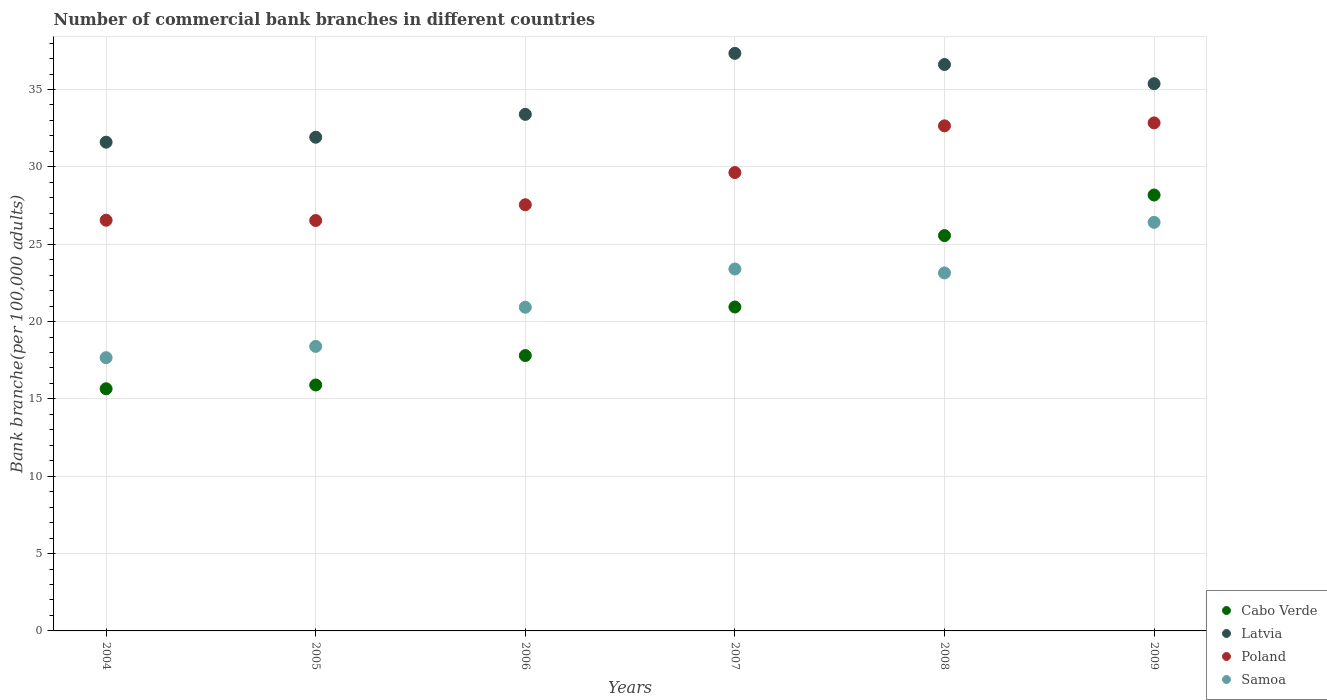How many different coloured dotlines are there?
Make the answer very short. 4. What is the number of commercial bank branches in Cabo Verde in 2008?
Offer a terse response. 25.56. Across all years, what is the maximum number of commercial bank branches in Latvia?
Your answer should be compact. 37.34. Across all years, what is the minimum number of commercial bank branches in Cabo Verde?
Give a very brief answer. 15.65. In which year was the number of commercial bank branches in Samoa maximum?
Offer a very short reply. 2009. In which year was the number of commercial bank branches in Latvia minimum?
Your response must be concise. 2004. What is the total number of commercial bank branches in Poland in the graph?
Provide a short and direct response. 175.76. What is the difference between the number of commercial bank branches in Samoa in 2005 and that in 2007?
Offer a terse response. -5. What is the difference between the number of commercial bank branches in Latvia in 2006 and the number of commercial bank branches in Samoa in 2005?
Offer a very short reply. 15. What is the average number of commercial bank branches in Poland per year?
Your answer should be very brief. 29.29. In the year 2004, what is the difference between the number of commercial bank branches in Cabo Verde and number of commercial bank branches in Samoa?
Your answer should be compact. -2.01. What is the ratio of the number of commercial bank branches in Poland in 2005 to that in 2009?
Keep it short and to the point. 0.81. Is the difference between the number of commercial bank branches in Cabo Verde in 2005 and 2006 greater than the difference between the number of commercial bank branches in Samoa in 2005 and 2006?
Your response must be concise. Yes. What is the difference between the highest and the second highest number of commercial bank branches in Latvia?
Your answer should be very brief. 0.72. What is the difference between the highest and the lowest number of commercial bank branches in Samoa?
Your answer should be very brief. 8.75. In how many years, is the number of commercial bank branches in Cabo Verde greater than the average number of commercial bank branches in Cabo Verde taken over all years?
Ensure brevity in your answer.  3. Is it the case that in every year, the sum of the number of commercial bank branches in Latvia and number of commercial bank branches in Poland  is greater than the number of commercial bank branches in Cabo Verde?
Provide a short and direct response. Yes. Does the number of commercial bank branches in Samoa monotonically increase over the years?
Offer a very short reply. No. Is the number of commercial bank branches in Cabo Verde strictly greater than the number of commercial bank branches in Latvia over the years?
Ensure brevity in your answer.  No. Is the number of commercial bank branches in Poland strictly less than the number of commercial bank branches in Cabo Verde over the years?
Offer a terse response. No. How many dotlines are there?
Your answer should be compact. 4. How many years are there in the graph?
Your answer should be very brief. 6. Does the graph contain any zero values?
Your answer should be very brief. No. What is the title of the graph?
Offer a very short reply. Number of commercial bank branches in different countries. Does "Benin" appear as one of the legend labels in the graph?
Offer a terse response. No. What is the label or title of the X-axis?
Ensure brevity in your answer.  Years. What is the label or title of the Y-axis?
Provide a succinct answer. Bank branche(per 100,0 adults). What is the Bank branche(per 100,000 adults) in Cabo Verde in 2004?
Your answer should be compact. 15.65. What is the Bank branche(per 100,000 adults) in Latvia in 2004?
Provide a succinct answer. 31.6. What is the Bank branche(per 100,000 adults) of Poland in 2004?
Your response must be concise. 26.55. What is the Bank branche(per 100,000 adults) of Samoa in 2004?
Offer a very short reply. 17.66. What is the Bank branche(per 100,000 adults) in Cabo Verde in 2005?
Your answer should be very brief. 15.9. What is the Bank branche(per 100,000 adults) in Latvia in 2005?
Your answer should be very brief. 31.92. What is the Bank branche(per 100,000 adults) of Poland in 2005?
Make the answer very short. 26.53. What is the Bank branche(per 100,000 adults) in Samoa in 2005?
Give a very brief answer. 18.39. What is the Bank branche(per 100,000 adults) of Cabo Verde in 2006?
Your answer should be very brief. 17.8. What is the Bank branche(per 100,000 adults) of Latvia in 2006?
Keep it short and to the point. 33.39. What is the Bank branche(per 100,000 adults) of Poland in 2006?
Make the answer very short. 27.55. What is the Bank branche(per 100,000 adults) of Samoa in 2006?
Provide a succinct answer. 20.92. What is the Bank branche(per 100,000 adults) in Cabo Verde in 2007?
Make the answer very short. 20.94. What is the Bank branche(per 100,000 adults) of Latvia in 2007?
Ensure brevity in your answer.  37.34. What is the Bank branche(per 100,000 adults) in Poland in 2007?
Offer a terse response. 29.63. What is the Bank branche(per 100,000 adults) in Samoa in 2007?
Your answer should be very brief. 23.4. What is the Bank branche(per 100,000 adults) of Cabo Verde in 2008?
Give a very brief answer. 25.56. What is the Bank branche(per 100,000 adults) in Latvia in 2008?
Your response must be concise. 36.62. What is the Bank branche(per 100,000 adults) in Poland in 2008?
Keep it short and to the point. 32.65. What is the Bank branche(per 100,000 adults) of Samoa in 2008?
Provide a short and direct response. 23.14. What is the Bank branche(per 100,000 adults) in Cabo Verde in 2009?
Your response must be concise. 28.18. What is the Bank branche(per 100,000 adults) of Latvia in 2009?
Your response must be concise. 35.38. What is the Bank branche(per 100,000 adults) in Poland in 2009?
Keep it short and to the point. 32.84. What is the Bank branche(per 100,000 adults) in Samoa in 2009?
Offer a terse response. 26.41. Across all years, what is the maximum Bank branche(per 100,000 adults) of Cabo Verde?
Offer a very short reply. 28.18. Across all years, what is the maximum Bank branche(per 100,000 adults) of Latvia?
Make the answer very short. 37.34. Across all years, what is the maximum Bank branche(per 100,000 adults) in Poland?
Keep it short and to the point. 32.84. Across all years, what is the maximum Bank branche(per 100,000 adults) in Samoa?
Provide a succinct answer. 26.41. Across all years, what is the minimum Bank branche(per 100,000 adults) of Cabo Verde?
Your response must be concise. 15.65. Across all years, what is the minimum Bank branche(per 100,000 adults) in Latvia?
Keep it short and to the point. 31.6. Across all years, what is the minimum Bank branche(per 100,000 adults) of Poland?
Keep it short and to the point. 26.53. Across all years, what is the minimum Bank branche(per 100,000 adults) in Samoa?
Provide a short and direct response. 17.66. What is the total Bank branche(per 100,000 adults) in Cabo Verde in the graph?
Offer a very short reply. 124.03. What is the total Bank branche(per 100,000 adults) in Latvia in the graph?
Ensure brevity in your answer.  206.23. What is the total Bank branche(per 100,000 adults) of Poland in the graph?
Make the answer very short. 175.76. What is the total Bank branche(per 100,000 adults) in Samoa in the graph?
Your response must be concise. 129.93. What is the difference between the Bank branche(per 100,000 adults) in Cabo Verde in 2004 and that in 2005?
Ensure brevity in your answer.  -0.24. What is the difference between the Bank branche(per 100,000 adults) in Latvia in 2004 and that in 2005?
Your response must be concise. -0.32. What is the difference between the Bank branche(per 100,000 adults) in Poland in 2004 and that in 2005?
Offer a terse response. 0.02. What is the difference between the Bank branche(per 100,000 adults) in Samoa in 2004 and that in 2005?
Your answer should be very brief. -0.73. What is the difference between the Bank branche(per 100,000 adults) of Cabo Verde in 2004 and that in 2006?
Your answer should be very brief. -2.15. What is the difference between the Bank branche(per 100,000 adults) in Latvia in 2004 and that in 2006?
Your response must be concise. -1.8. What is the difference between the Bank branche(per 100,000 adults) of Poland in 2004 and that in 2006?
Your answer should be compact. -1. What is the difference between the Bank branche(per 100,000 adults) in Samoa in 2004 and that in 2006?
Offer a very short reply. -3.26. What is the difference between the Bank branche(per 100,000 adults) in Cabo Verde in 2004 and that in 2007?
Give a very brief answer. -5.29. What is the difference between the Bank branche(per 100,000 adults) of Latvia in 2004 and that in 2007?
Provide a succinct answer. -5.74. What is the difference between the Bank branche(per 100,000 adults) of Poland in 2004 and that in 2007?
Offer a very short reply. -3.08. What is the difference between the Bank branche(per 100,000 adults) in Samoa in 2004 and that in 2007?
Offer a very short reply. -5.73. What is the difference between the Bank branche(per 100,000 adults) in Cabo Verde in 2004 and that in 2008?
Ensure brevity in your answer.  -9.9. What is the difference between the Bank branche(per 100,000 adults) in Latvia in 2004 and that in 2008?
Make the answer very short. -5.02. What is the difference between the Bank branche(per 100,000 adults) in Poland in 2004 and that in 2008?
Provide a succinct answer. -6.1. What is the difference between the Bank branche(per 100,000 adults) of Samoa in 2004 and that in 2008?
Make the answer very short. -5.48. What is the difference between the Bank branche(per 100,000 adults) of Cabo Verde in 2004 and that in 2009?
Offer a very short reply. -12.53. What is the difference between the Bank branche(per 100,000 adults) of Latvia in 2004 and that in 2009?
Offer a very short reply. -3.78. What is the difference between the Bank branche(per 100,000 adults) in Poland in 2004 and that in 2009?
Ensure brevity in your answer.  -6.29. What is the difference between the Bank branche(per 100,000 adults) in Samoa in 2004 and that in 2009?
Provide a succinct answer. -8.75. What is the difference between the Bank branche(per 100,000 adults) in Cabo Verde in 2005 and that in 2006?
Ensure brevity in your answer.  -1.9. What is the difference between the Bank branche(per 100,000 adults) in Latvia in 2005 and that in 2006?
Your answer should be compact. -1.48. What is the difference between the Bank branche(per 100,000 adults) of Poland in 2005 and that in 2006?
Your response must be concise. -1.02. What is the difference between the Bank branche(per 100,000 adults) of Samoa in 2005 and that in 2006?
Offer a terse response. -2.53. What is the difference between the Bank branche(per 100,000 adults) of Cabo Verde in 2005 and that in 2007?
Offer a very short reply. -5.04. What is the difference between the Bank branche(per 100,000 adults) of Latvia in 2005 and that in 2007?
Your response must be concise. -5.42. What is the difference between the Bank branche(per 100,000 adults) of Poland in 2005 and that in 2007?
Ensure brevity in your answer.  -3.1. What is the difference between the Bank branche(per 100,000 adults) in Samoa in 2005 and that in 2007?
Offer a terse response. -5. What is the difference between the Bank branche(per 100,000 adults) in Cabo Verde in 2005 and that in 2008?
Offer a terse response. -9.66. What is the difference between the Bank branche(per 100,000 adults) in Latvia in 2005 and that in 2008?
Your answer should be compact. -4.7. What is the difference between the Bank branche(per 100,000 adults) in Poland in 2005 and that in 2008?
Your answer should be compact. -6.12. What is the difference between the Bank branche(per 100,000 adults) in Samoa in 2005 and that in 2008?
Give a very brief answer. -4.75. What is the difference between the Bank branche(per 100,000 adults) in Cabo Verde in 2005 and that in 2009?
Keep it short and to the point. -12.28. What is the difference between the Bank branche(per 100,000 adults) of Latvia in 2005 and that in 2009?
Provide a short and direct response. -3.46. What is the difference between the Bank branche(per 100,000 adults) in Poland in 2005 and that in 2009?
Your answer should be compact. -6.31. What is the difference between the Bank branche(per 100,000 adults) of Samoa in 2005 and that in 2009?
Keep it short and to the point. -8.02. What is the difference between the Bank branche(per 100,000 adults) of Cabo Verde in 2006 and that in 2007?
Ensure brevity in your answer.  -3.14. What is the difference between the Bank branche(per 100,000 adults) of Latvia in 2006 and that in 2007?
Provide a short and direct response. -3.94. What is the difference between the Bank branche(per 100,000 adults) in Poland in 2006 and that in 2007?
Provide a succinct answer. -2.08. What is the difference between the Bank branche(per 100,000 adults) in Samoa in 2006 and that in 2007?
Keep it short and to the point. -2.47. What is the difference between the Bank branche(per 100,000 adults) in Cabo Verde in 2006 and that in 2008?
Keep it short and to the point. -7.76. What is the difference between the Bank branche(per 100,000 adults) in Latvia in 2006 and that in 2008?
Your response must be concise. -3.22. What is the difference between the Bank branche(per 100,000 adults) of Poland in 2006 and that in 2008?
Offer a terse response. -5.1. What is the difference between the Bank branche(per 100,000 adults) in Samoa in 2006 and that in 2008?
Offer a very short reply. -2.22. What is the difference between the Bank branche(per 100,000 adults) of Cabo Verde in 2006 and that in 2009?
Give a very brief answer. -10.38. What is the difference between the Bank branche(per 100,000 adults) in Latvia in 2006 and that in 2009?
Offer a very short reply. -1.98. What is the difference between the Bank branche(per 100,000 adults) of Poland in 2006 and that in 2009?
Your answer should be compact. -5.29. What is the difference between the Bank branche(per 100,000 adults) in Samoa in 2006 and that in 2009?
Your response must be concise. -5.49. What is the difference between the Bank branche(per 100,000 adults) of Cabo Verde in 2007 and that in 2008?
Give a very brief answer. -4.62. What is the difference between the Bank branche(per 100,000 adults) of Latvia in 2007 and that in 2008?
Ensure brevity in your answer.  0.72. What is the difference between the Bank branche(per 100,000 adults) in Poland in 2007 and that in 2008?
Ensure brevity in your answer.  -3.02. What is the difference between the Bank branche(per 100,000 adults) of Samoa in 2007 and that in 2008?
Offer a very short reply. 0.26. What is the difference between the Bank branche(per 100,000 adults) in Cabo Verde in 2007 and that in 2009?
Provide a succinct answer. -7.24. What is the difference between the Bank branche(per 100,000 adults) of Latvia in 2007 and that in 2009?
Offer a terse response. 1.96. What is the difference between the Bank branche(per 100,000 adults) in Poland in 2007 and that in 2009?
Your answer should be compact. -3.21. What is the difference between the Bank branche(per 100,000 adults) in Samoa in 2007 and that in 2009?
Make the answer very short. -3.02. What is the difference between the Bank branche(per 100,000 adults) in Cabo Verde in 2008 and that in 2009?
Keep it short and to the point. -2.62. What is the difference between the Bank branche(per 100,000 adults) of Latvia in 2008 and that in 2009?
Offer a terse response. 1.24. What is the difference between the Bank branche(per 100,000 adults) in Poland in 2008 and that in 2009?
Make the answer very short. -0.19. What is the difference between the Bank branche(per 100,000 adults) of Samoa in 2008 and that in 2009?
Your answer should be compact. -3.27. What is the difference between the Bank branche(per 100,000 adults) in Cabo Verde in 2004 and the Bank branche(per 100,000 adults) in Latvia in 2005?
Your answer should be very brief. -16.26. What is the difference between the Bank branche(per 100,000 adults) in Cabo Verde in 2004 and the Bank branche(per 100,000 adults) in Poland in 2005?
Provide a short and direct response. -10.88. What is the difference between the Bank branche(per 100,000 adults) in Cabo Verde in 2004 and the Bank branche(per 100,000 adults) in Samoa in 2005?
Provide a short and direct response. -2.74. What is the difference between the Bank branche(per 100,000 adults) in Latvia in 2004 and the Bank branche(per 100,000 adults) in Poland in 2005?
Make the answer very short. 5.06. What is the difference between the Bank branche(per 100,000 adults) of Latvia in 2004 and the Bank branche(per 100,000 adults) of Samoa in 2005?
Keep it short and to the point. 13.2. What is the difference between the Bank branche(per 100,000 adults) in Poland in 2004 and the Bank branche(per 100,000 adults) in Samoa in 2005?
Your answer should be compact. 8.16. What is the difference between the Bank branche(per 100,000 adults) of Cabo Verde in 2004 and the Bank branche(per 100,000 adults) of Latvia in 2006?
Make the answer very short. -17.74. What is the difference between the Bank branche(per 100,000 adults) in Cabo Verde in 2004 and the Bank branche(per 100,000 adults) in Poland in 2006?
Provide a short and direct response. -11.9. What is the difference between the Bank branche(per 100,000 adults) of Cabo Verde in 2004 and the Bank branche(per 100,000 adults) of Samoa in 2006?
Give a very brief answer. -5.27. What is the difference between the Bank branche(per 100,000 adults) of Latvia in 2004 and the Bank branche(per 100,000 adults) of Poland in 2006?
Your response must be concise. 4.04. What is the difference between the Bank branche(per 100,000 adults) in Latvia in 2004 and the Bank branche(per 100,000 adults) in Samoa in 2006?
Offer a very short reply. 10.67. What is the difference between the Bank branche(per 100,000 adults) in Poland in 2004 and the Bank branche(per 100,000 adults) in Samoa in 2006?
Offer a terse response. 5.63. What is the difference between the Bank branche(per 100,000 adults) in Cabo Verde in 2004 and the Bank branche(per 100,000 adults) in Latvia in 2007?
Keep it short and to the point. -21.68. What is the difference between the Bank branche(per 100,000 adults) in Cabo Verde in 2004 and the Bank branche(per 100,000 adults) in Poland in 2007?
Offer a terse response. -13.98. What is the difference between the Bank branche(per 100,000 adults) of Cabo Verde in 2004 and the Bank branche(per 100,000 adults) of Samoa in 2007?
Make the answer very short. -7.74. What is the difference between the Bank branche(per 100,000 adults) in Latvia in 2004 and the Bank branche(per 100,000 adults) in Poland in 2007?
Your response must be concise. 1.96. What is the difference between the Bank branche(per 100,000 adults) of Latvia in 2004 and the Bank branche(per 100,000 adults) of Samoa in 2007?
Your answer should be very brief. 8.2. What is the difference between the Bank branche(per 100,000 adults) of Poland in 2004 and the Bank branche(per 100,000 adults) of Samoa in 2007?
Your answer should be very brief. 3.15. What is the difference between the Bank branche(per 100,000 adults) in Cabo Verde in 2004 and the Bank branche(per 100,000 adults) in Latvia in 2008?
Your answer should be very brief. -20.96. What is the difference between the Bank branche(per 100,000 adults) of Cabo Verde in 2004 and the Bank branche(per 100,000 adults) of Poland in 2008?
Keep it short and to the point. -17. What is the difference between the Bank branche(per 100,000 adults) in Cabo Verde in 2004 and the Bank branche(per 100,000 adults) in Samoa in 2008?
Ensure brevity in your answer.  -7.49. What is the difference between the Bank branche(per 100,000 adults) in Latvia in 2004 and the Bank branche(per 100,000 adults) in Poland in 2008?
Make the answer very short. -1.06. What is the difference between the Bank branche(per 100,000 adults) of Latvia in 2004 and the Bank branche(per 100,000 adults) of Samoa in 2008?
Give a very brief answer. 8.45. What is the difference between the Bank branche(per 100,000 adults) in Poland in 2004 and the Bank branche(per 100,000 adults) in Samoa in 2008?
Offer a very short reply. 3.41. What is the difference between the Bank branche(per 100,000 adults) of Cabo Verde in 2004 and the Bank branche(per 100,000 adults) of Latvia in 2009?
Your answer should be compact. -19.72. What is the difference between the Bank branche(per 100,000 adults) of Cabo Verde in 2004 and the Bank branche(per 100,000 adults) of Poland in 2009?
Give a very brief answer. -17.19. What is the difference between the Bank branche(per 100,000 adults) in Cabo Verde in 2004 and the Bank branche(per 100,000 adults) in Samoa in 2009?
Your answer should be compact. -10.76. What is the difference between the Bank branche(per 100,000 adults) in Latvia in 2004 and the Bank branche(per 100,000 adults) in Poland in 2009?
Provide a short and direct response. -1.25. What is the difference between the Bank branche(per 100,000 adults) in Latvia in 2004 and the Bank branche(per 100,000 adults) in Samoa in 2009?
Give a very brief answer. 5.18. What is the difference between the Bank branche(per 100,000 adults) in Poland in 2004 and the Bank branche(per 100,000 adults) in Samoa in 2009?
Your response must be concise. 0.14. What is the difference between the Bank branche(per 100,000 adults) of Cabo Verde in 2005 and the Bank branche(per 100,000 adults) of Latvia in 2006?
Offer a very short reply. -17.49. What is the difference between the Bank branche(per 100,000 adults) of Cabo Verde in 2005 and the Bank branche(per 100,000 adults) of Poland in 2006?
Ensure brevity in your answer.  -11.65. What is the difference between the Bank branche(per 100,000 adults) in Cabo Verde in 2005 and the Bank branche(per 100,000 adults) in Samoa in 2006?
Keep it short and to the point. -5.02. What is the difference between the Bank branche(per 100,000 adults) in Latvia in 2005 and the Bank branche(per 100,000 adults) in Poland in 2006?
Ensure brevity in your answer.  4.36. What is the difference between the Bank branche(per 100,000 adults) of Latvia in 2005 and the Bank branche(per 100,000 adults) of Samoa in 2006?
Offer a very short reply. 10.99. What is the difference between the Bank branche(per 100,000 adults) in Poland in 2005 and the Bank branche(per 100,000 adults) in Samoa in 2006?
Your answer should be very brief. 5.61. What is the difference between the Bank branche(per 100,000 adults) in Cabo Verde in 2005 and the Bank branche(per 100,000 adults) in Latvia in 2007?
Give a very brief answer. -21.44. What is the difference between the Bank branche(per 100,000 adults) in Cabo Verde in 2005 and the Bank branche(per 100,000 adults) in Poland in 2007?
Your answer should be compact. -13.73. What is the difference between the Bank branche(per 100,000 adults) in Cabo Verde in 2005 and the Bank branche(per 100,000 adults) in Samoa in 2007?
Give a very brief answer. -7.5. What is the difference between the Bank branche(per 100,000 adults) in Latvia in 2005 and the Bank branche(per 100,000 adults) in Poland in 2007?
Give a very brief answer. 2.28. What is the difference between the Bank branche(per 100,000 adults) in Latvia in 2005 and the Bank branche(per 100,000 adults) in Samoa in 2007?
Your response must be concise. 8.52. What is the difference between the Bank branche(per 100,000 adults) in Poland in 2005 and the Bank branche(per 100,000 adults) in Samoa in 2007?
Your answer should be very brief. 3.13. What is the difference between the Bank branche(per 100,000 adults) of Cabo Verde in 2005 and the Bank branche(per 100,000 adults) of Latvia in 2008?
Offer a very short reply. -20.72. What is the difference between the Bank branche(per 100,000 adults) in Cabo Verde in 2005 and the Bank branche(per 100,000 adults) in Poland in 2008?
Provide a short and direct response. -16.75. What is the difference between the Bank branche(per 100,000 adults) of Cabo Verde in 2005 and the Bank branche(per 100,000 adults) of Samoa in 2008?
Your response must be concise. -7.24. What is the difference between the Bank branche(per 100,000 adults) in Latvia in 2005 and the Bank branche(per 100,000 adults) in Poland in 2008?
Your answer should be compact. -0.74. What is the difference between the Bank branche(per 100,000 adults) of Latvia in 2005 and the Bank branche(per 100,000 adults) of Samoa in 2008?
Offer a terse response. 8.77. What is the difference between the Bank branche(per 100,000 adults) of Poland in 2005 and the Bank branche(per 100,000 adults) of Samoa in 2008?
Give a very brief answer. 3.39. What is the difference between the Bank branche(per 100,000 adults) in Cabo Verde in 2005 and the Bank branche(per 100,000 adults) in Latvia in 2009?
Provide a short and direct response. -19.48. What is the difference between the Bank branche(per 100,000 adults) in Cabo Verde in 2005 and the Bank branche(per 100,000 adults) in Poland in 2009?
Keep it short and to the point. -16.94. What is the difference between the Bank branche(per 100,000 adults) in Cabo Verde in 2005 and the Bank branche(per 100,000 adults) in Samoa in 2009?
Offer a very short reply. -10.51. What is the difference between the Bank branche(per 100,000 adults) in Latvia in 2005 and the Bank branche(per 100,000 adults) in Poland in 2009?
Ensure brevity in your answer.  -0.93. What is the difference between the Bank branche(per 100,000 adults) in Latvia in 2005 and the Bank branche(per 100,000 adults) in Samoa in 2009?
Offer a terse response. 5.5. What is the difference between the Bank branche(per 100,000 adults) of Poland in 2005 and the Bank branche(per 100,000 adults) of Samoa in 2009?
Ensure brevity in your answer.  0.12. What is the difference between the Bank branche(per 100,000 adults) in Cabo Verde in 2006 and the Bank branche(per 100,000 adults) in Latvia in 2007?
Give a very brief answer. -19.54. What is the difference between the Bank branche(per 100,000 adults) in Cabo Verde in 2006 and the Bank branche(per 100,000 adults) in Poland in 2007?
Make the answer very short. -11.83. What is the difference between the Bank branche(per 100,000 adults) in Cabo Verde in 2006 and the Bank branche(per 100,000 adults) in Samoa in 2007?
Your answer should be compact. -5.6. What is the difference between the Bank branche(per 100,000 adults) of Latvia in 2006 and the Bank branche(per 100,000 adults) of Poland in 2007?
Ensure brevity in your answer.  3.76. What is the difference between the Bank branche(per 100,000 adults) in Latvia in 2006 and the Bank branche(per 100,000 adults) in Samoa in 2007?
Make the answer very short. 10. What is the difference between the Bank branche(per 100,000 adults) of Poland in 2006 and the Bank branche(per 100,000 adults) of Samoa in 2007?
Your response must be concise. 4.15. What is the difference between the Bank branche(per 100,000 adults) of Cabo Verde in 2006 and the Bank branche(per 100,000 adults) of Latvia in 2008?
Your answer should be very brief. -18.81. What is the difference between the Bank branche(per 100,000 adults) of Cabo Verde in 2006 and the Bank branche(per 100,000 adults) of Poland in 2008?
Offer a terse response. -14.85. What is the difference between the Bank branche(per 100,000 adults) of Cabo Verde in 2006 and the Bank branche(per 100,000 adults) of Samoa in 2008?
Make the answer very short. -5.34. What is the difference between the Bank branche(per 100,000 adults) in Latvia in 2006 and the Bank branche(per 100,000 adults) in Poland in 2008?
Keep it short and to the point. 0.74. What is the difference between the Bank branche(per 100,000 adults) of Latvia in 2006 and the Bank branche(per 100,000 adults) of Samoa in 2008?
Your answer should be compact. 10.25. What is the difference between the Bank branche(per 100,000 adults) of Poland in 2006 and the Bank branche(per 100,000 adults) of Samoa in 2008?
Provide a short and direct response. 4.41. What is the difference between the Bank branche(per 100,000 adults) in Cabo Verde in 2006 and the Bank branche(per 100,000 adults) in Latvia in 2009?
Provide a succinct answer. -17.57. What is the difference between the Bank branche(per 100,000 adults) in Cabo Verde in 2006 and the Bank branche(per 100,000 adults) in Poland in 2009?
Provide a short and direct response. -15.04. What is the difference between the Bank branche(per 100,000 adults) in Cabo Verde in 2006 and the Bank branche(per 100,000 adults) in Samoa in 2009?
Keep it short and to the point. -8.61. What is the difference between the Bank branche(per 100,000 adults) of Latvia in 2006 and the Bank branche(per 100,000 adults) of Poland in 2009?
Offer a terse response. 0.55. What is the difference between the Bank branche(per 100,000 adults) in Latvia in 2006 and the Bank branche(per 100,000 adults) in Samoa in 2009?
Make the answer very short. 6.98. What is the difference between the Bank branche(per 100,000 adults) in Poland in 2006 and the Bank branche(per 100,000 adults) in Samoa in 2009?
Make the answer very short. 1.14. What is the difference between the Bank branche(per 100,000 adults) of Cabo Verde in 2007 and the Bank branche(per 100,000 adults) of Latvia in 2008?
Offer a terse response. -15.68. What is the difference between the Bank branche(per 100,000 adults) of Cabo Verde in 2007 and the Bank branche(per 100,000 adults) of Poland in 2008?
Offer a very short reply. -11.71. What is the difference between the Bank branche(per 100,000 adults) in Cabo Verde in 2007 and the Bank branche(per 100,000 adults) in Samoa in 2008?
Offer a very short reply. -2.2. What is the difference between the Bank branche(per 100,000 adults) of Latvia in 2007 and the Bank branche(per 100,000 adults) of Poland in 2008?
Make the answer very short. 4.69. What is the difference between the Bank branche(per 100,000 adults) of Latvia in 2007 and the Bank branche(per 100,000 adults) of Samoa in 2008?
Make the answer very short. 14.2. What is the difference between the Bank branche(per 100,000 adults) in Poland in 2007 and the Bank branche(per 100,000 adults) in Samoa in 2008?
Offer a terse response. 6.49. What is the difference between the Bank branche(per 100,000 adults) of Cabo Verde in 2007 and the Bank branche(per 100,000 adults) of Latvia in 2009?
Provide a succinct answer. -14.44. What is the difference between the Bank branche(per 100,000 adults) of Cabo Verde in 2007 and the Bank branche(per 100,000 adults) of Poland in 2009?
Make the answer very short. -11.9. What is the difference between the Bank branche(per 100,000 adults) in Cabo Verde in 2007 and the Bank branche(per 100,000 adults) in Samoa in 2009?
Ensure brevity in your answer.  -5.47. What is the difference between the Bank branche(per 100,000 adults) in Latvia in 2007 and the Bank branche(per 100,000 adults) in Poland in 2009?
Give a very brief answer. 4.5. What is the difference between the Bank branche(per 100,000 adults) of Latvia in 2007 and the Bank branche(per 100,000 adults) of Samoa in 2009?
Your answer should be very brief. 10.93. What is the difference between the Bank branche(per 100,000 adults) of Poland in 2007 and the Bank branche(per 100,000 adults) of Samoa in 2009?
Your answer should be compact. 3.22. What is the difference between the Bank branche(per 100,000 adults) of Cabo Verde in 2008 and the Bank branche(per 100,000 adults) of Latvia in 2009?
Your answer should be very brief. -9.82. What is the difference between the Bank branche(per 100,000 adults) in Cabo Verde in 2008 and the Bank branche(per 100,000 adults) in Poland in 2009?
Make the answer very short. -7.28. What is the difference between the Bank branche(per 100,000 adults) of Cabo Verde in 2008 and the Bank branche(per 100,000 adults) of Samoa in 2009?
Keep it short and to the point. -0.86. What is the difference between the Bank branche(per 100,000 adults) of Latvia in 2008 and the Bank branche(per 100,000 adults) of Poland in 2009?
Your response must be concise. 3.77. What is the difference between the Bank branche(per 100,000 adults) of Latvia in 2008 and the Bank branche(per 100,000 adults) of Samoa in 2009?
Your response must be concise. 10.2. What is the difference between the Bank branche(per 100,000 adults) of Poland in 2008 and the Bank branche(per 100,000 adults) of Samoa in 2009?
Provide a short and direct response. 6.24. What is the average Bank branche(per 100,000 adults) of Cabo Verde per year?
Keep it short and to the point. 20.67. What is the average Bank branche(per 100,000 adults) in Latvia per year?
Your response must be concise. 34.37. What is the average Bank branche(per 100,000 adults) of Poland per year?
Your response must be concise. 29.29. What is the average Bank branche(per 100,000 adults) in Samoa per year?
Make the answer very short. 21.66. In the year 2004, what is the difference between the Bank branche(per 100,000 adults) of Cabo Verde and Bank branche(per 100,000 adults) of Latvia?
Your response must be concise. -15.94. In the year 2004, what is the difference between the Bank branche(per 100,000 adults) of Cabo Verde and Bank branche(per 100,000 adults) of Poland?
Your answer should be compact. -10.9. In the year 2004, what is the difference between the Bank branche(per 100,000 adults) of Cabo Verde and Bank branche(per 100,000 adults) of Samoa?
Ensure brevity in your answer.  -2.01. In the year 2004, what is the difference between the Bank branche(per 100,000 adults) in Latvia and Bank branche(per 100,000 adults) in Poland?
Your answer should be compact. 5.04. In the year 2004, what is the difference between the Bank branche(per 100,000 adults) of Latvia and Bank branche(per 100,000 adults) of Samoa?
Your answer should be compact. 13.93. In the year 2004, what is the difference between the Bank branche(per 100,000 adults) of Poland and Bank branche(per 100,000 adults) of Samoa?
Your answer should be very brief. 8.89. In the year 2005, what is the difference between the Bank branche(per 100,000 adults) in Cabo Verde and Bank branche(per 100,000 adults) in Latvia?
Give a very brief answer. -16.02. In the year 2005, what is the difference between the Bank branche(per 100,000 adults) in Cabo Verde and Bank branche(per 100,000 adults) in Poland?
Keep it short and to the point. -10.63. In the year 2005, what is the difference between the Bank branche(per 100,000 adults) in Cabo Verde and Bank branche(per 100,000 adults) in Samoa?
Offer a terse response. -2.49. In the year 2005, what is the difference between the Bank branche(per 100,000 adults) in Latvia and Bank branche(per 100,000 adults) in Poland?
Ensure brevity in your answer.  5.38. In the year 2005, what is the difference between the Bank branche(per 100,000 adults) of Latvia and Bank branche(per 100,000 adults) of Samoa?
Provide a short and direct response. 13.52. In the year 2005, what is the difference between the Bank branche(per 100,000 adults) in Poland and Bank branche(per 100,000 adults) in Samoa?
Your answer should be very brief. 8.14. In the year 2006, what is the difference between the Bank branche(per 100,000 adults) in Cabo Verde and Bank branche(per 100,000 adults) in Latvia?
Make the answer very short. -15.59. In the year 2006, what is the difference between the Bank branche(per 100,000 adults) of Cabo Verde and Bank branche(per 100,000 adults) of Poland?
Your response must be concise. -9.75. In the year 2006, what is the difference between the Bank branche(per 100,000 adults) of Cabo Verde and Bank branche(per 100,000 adults) of Samoa?
Your answer should be compact. -3.12. In the year 2006, what is the difference between the Bank branche(per 100,000 adults) of Latvia and Bank branche(per 100,000 adults) of Poland?
Your answer should be compact. 5.84. In the year 2006, what is the difference between the Bank branche(per 100,000 adults) in Latvia and Bank branche(per 100,000 adults) in Samoa?
Make the answer very short. 12.47. In the year 2006, what is the difference between the Bank branche(per 100,000 adults) of Poland and Bank branche(per 100,000 adults) of Samoa?
Give a very brief answer. 6.63. In the year 2007, what is the difference between the Bank branche(per 100,000 adults) in Cabo Verde and Bank branche(per 100,000 adults) in Latvia?
Provide a short and direct response. -16.4. In the year 2007, what is the difference between the Bank branche(per 100,000 adults) of Cabo Verde and Bank branche(per 100,000 adults) of Poland?
Keep it short and to the point. -8.69. In the year 2007, what is the difference between the Bank branche(per 100,000 adults) of Cabo Verde and Bank branche(per 100,000 adults) of Samoa?
Your response must be concise. -2.46. In the year 2007, what is the difference between the Bank branche(per 100,000 adults) in Latvia and Bank branche(per 100,000 adults) in Poland?
Provide a succinct answer. 7.71. In the year 2007, what is the difference between the Bank branche(per 100,000 adults) of Latvia and Bank branche(per 100,000 adults) of Samoa?
Offer a very short reply. 13.94. In the year 2007, what is the difference between the Bank branche(per 100,000 adults) of Poland and Bank branche(per 100,000 adults) of Samoa?
Provide a short and direct response. 6.24. In the year 2008, what is the difference between the Bank branche(per 100,000 adults) of Cabo Verde and Bank branche(per 100,000 adults) of Latvia?
Provide a short and direct response. -11.06. In the year 2008, what is the difference between the Bank branche(per 100,000 adults) of Cabo Verde and Bank branche(per 100,000 adults) of Poland?
Keep it short and to the point. -7.09. In the year 2008, what is the difference between the Bank branche(per 100,000 adults) of Cabo Verde and Bank branche(per 100,000 adults) of Samoa?
Your answer should be very brief. 2.41. In the year 2008, what is the difference between the Bank branche(per 100,000 adults) in Latvia and Bank branche(per 100,000 adults) in Poland?
Make the answer very short. 3.96. In the year 2008, what is the difference between the Bank branche(per 100,000 adults) in Latvia and Bank branche(per 100,000 adults) in Samoa?
Your response must be concise. 13.47. In the year 2008, what is the difference between the Bank branche(per 100,000 adults) in Poland and Bank branche(per 100,000 adults) in Samoa?
Offer a very short reply. 9.51. In the year 2009, what is the difference between the Bank branche(per 100,000 adults) of Cabo Verde and Bank branche(per 100,000 adults) of Latvia?
Make the answer very short. -7.2. In the year 2009, what is the difference between the Bank branche(per 100,000 adults) of Cabo Verde and Bank branche(per 100,000 adults) of Poland?
Give a very brief answer. -4.66. In the year 2009, what is the difference between the Bank branche(per 100,000 adults) in Cabo Verde and Bank branche(per 100,000 adults) in Samoa?
Give a very brief answer. 1.77. In the year 2009, what is the difference between the Bank branche(per 100,000 adults) in Latvia and Bank branche(per 100,000 adults) in Poland?
Make the answer very short. 2.53. In the year 2009, what is the difference between the Bank branche(per 100,000 adults) of Latvia and Bank branche(per 100,000 adults) of Samoa?
Provide a short and direct response. 8.96. In the year 2009, what is the difference between the Bank branche(per 100,000 adults) of Poland and Bank branche(per 100,000 adults) of Samoa?
Ensure brevity in your answer.  6.43. What is the ratio of the Bank branche(per 100,000 adults) in Cabo Verde in 2004 to that in 2005?
Offer a very short reply. 0.98. What is the ratio of the Bank branche(per 100,000 adults) of Latvia in 2004 to that in 2005?
Your answer should be compact. 0.99. What is the ratio of the Bank branche(per 100,000 adults) of Poland in 2004 to that in 2005?
Offer a very short reply. 1. What is the ratio of the Bank branche(per 100,000 adults) of Samoa in 2004 to that in 2005?
Ensure brevity in your answer.  0.96. What is the ratio of the Bank branche(per 100,000 adults) in Cabo Verde in 2004 to that in 2006?
Your response must be concise. 0.88. What is the ratio of the Bank branche(per 100,000 adults) of Latvia in 2004 to that in 2006?
Provide a short and direct response. 0.95. What is the ratio of the Bank branche(per 100,000 adults) in Poland in 2004 to that in 2006?
Offer a terse response. 0.96. What is the ratio of the Bank branche(per 100,000 adults) in Samoa in 2004 to that in 2006?
Give a very brief answer. 0.84. What is the ratio of the Bank branche(per 100,000 adults) in Cabo Verde in 2004 to that in 2007?
Give a very brief answer. 0.75. What is the ratio of the Bank branche(per 100,000 adults) of Latvia in 2004 to that in 2007?
Your response must be concise. 0.85. What is the ratio of the Bank branche(per 100,000 adults) of Poland in 2004 to that in 2007?
Make the answer very short. 0.9. What is the ratio of the Bank branche(per 100,000 adults) in Samoa in 2004 to that in 2007?
Give a very brief answer. 0.76. What is the ratio of the Bank branche(per 100,000 adults) in Cabo Verde in 2004 to that in 2008?
Provide a short and direct response. 0.61. What is the ratio of the Bank branche(per 100,000 adults) in Latvia in 2004 to that in 2008?
Your answer should be compact. 0.86. What is the ratio of the Bank branche(per 100,000 adults) of Poland in 2004 to that in 2008?
Give a very brief answer. 0.81. What is the ratio of the Bank branche(per 100,000 adults) of Samoa in 2004 to that in 2008?
Give a very brief answer. 0.76. What is the ratio of the Bank branche(per 100,000 adults) of Cabo Verde in 2004 to that in 2009?
Give a very brief answer. 0.56. What is the ratio of the Bank branche(per 100,000 adults) of Latvia in 2004 to that in 2009?
Keep it short and to the point. 0.89. What is the ratio of the Bank branche(per 100,000 adults) in Poland in 2004 to that in 2009?
Provide a short and direct response. 0.81. What is the ratio of the Bank branche(per 100,000 adults) of Samoa in 2004 to that in 2009?
Keep it short and to the point. 0.67. What is the ratio of the Bank branche(per 100,000 adults) of Cabo Verde in 2005 to that in 2006?
Provide a short and direct response. 0.89. What is the ratio of the Bank branche(per 100,000 adults) of Latvia in 2005 to that in 2006?
Your response must be concise. 0.96. What is the ratio of the Bank branche(per 100,000 adults) of Samoa in 2005 to that in 2006?
Give a very brief answer. 0.88. What is the ratio of the Bank branche(per 100,000 adults) in Cabo Verde in 2005 to that in 2007?
Provide a short and direct response. 0.76. What is the ratio of the Bank branche(per 100,000 adults) in Latvia in 2005 to that in 2007?
Your answer should be very brief. 0.85. What is the ratio of the Bank branche(per 100,000 adults) of Poland in 2005 to that in 2007?
Offer a very short reply. 0.9. What is the ratio of the Bank branche(per 100,000 adults) of Samoa in 2005 to that in 2007?
Provide a short and direct response. 0.79. What is the ratio of the Bank branche(per 100,000 adults) of Cabo Verde in 2005 to that in 2008?
Your response must be concise. 0.62. What is the ratio of the Bank branche(per 100,000 adults) of Latvia in 2005 to that in 2008?
Make the answer very short. 0.87. What is the ratio of the Bank branche(per 100,000 adults) of Poland in 2005 to that in 2008?
Offer a very short reply. 0.81. What is the ratio of the Bank branche(per 100,000 adults) of Samoa in 2005 to that in 2008?
Your response must be concise. 0.79. What is the ratio of the Bank branche(per 100,000 adults) in Cabo Verde in 2005 to that in 2009?
Keep it short and to the point. 0.56. What is the ratio of the Bank branche(per 100,000 adults) in Latvia in 2005 to that in 2009?
Offer a very short reply. 0.9. What is the ratio of the Bank branche(per 100,000 adults) in Poland in 2005 to that in 2009?
Offer a very short reply. 0.81. What is the ratio of the Bank branche(per 100,000 adults) in Samoa in 2005 to that in 2009?
Provide a succinct answer. 0.7. What is the ratio of the Bank branche(per 100,000 adults) of Cabo Verde in 2006 to that in 2007?
Your response must be concise. 0.85. What is the ratio of the Bank branche(per 100,000 adults) of Latvia in 2006 to that in 2007?
Your answer should be very brief. 0.89. What is the ratio of the Bank branche(per 100,000 adults) of Poland in 2006 to that in 2007?
Keep it short and to the point. 0.93. What is the ratio of the Bank branche(per 100,000 adults) in Samoa in 2006 to that in 2007?
Make the answer very short. 0.89. What is the ratio of the Bank branche(per 100,000 adults) of Cabo Verde in 2006 to that in 2008?
Give a very brief answer. 0.7. What is the ratio of the Bank branche(per 100,000 adults) in Latvia in 2006 to that in 2008?
Your answer should be compact. 0.91. What is the ratio of the Bank branche(per 100,000 adults) of Poland in 2006 to that in 2008?
Make the answer very short. 0.84. What is the ratio of the Bank branche(per 100,000 adults) in Samoa in 2006 to that in 2008?
Provide a short and direct response. 0.9. What is the ratio of the Bank branche(per 100,000 adults) of Cabo Verde in 2006 to that in 2009?
Provide a short and direct response. 0.63. What is the ratio of the Bank branche(per 100,000 adults) in Latvia in 2006 to that in 2009?
Ensure brevity in your answer.  0.94. What is the ratio of the Bank branche(per 100,000 adults) in Poland in 2006 to that in 2009?
Your response must be concise. 0.84. What is the ratio of the Bank branche(per 100,000 adults) in Samoa in 2006 to that in 2009?
Offer a terse response. 0.79. What is the ratio of the Bank branche(per 100,000 adults) in Cabo Verde in 2007 to that in 2008?
Offer a very short reply. 0.82. What is the ratio of the Bank branche(per 100,000 adults) of Latvia in 2007 to that in 2008?
Make the answer very short. 1.02. What is the ratio of the Bank branche(per 100,000 adults) in Poland in 2007 to that in 2008?
Make the answer very short. 0.91. What is the ratio of the Bank branche(per 100,000 adults) of Cabo Verde in 2007 to that in 2009?
Ensure brevity in your answer.  0.74. What is the ratio of the Bank branche(per 100,000 adults) in Latvia in 2007 to that in 2009?
Your answer should be compact. 1.06. What is the ratio of the Bank branche(per 100,000 adults) in Poland in 2007 to that in 2009?
Your answer should be compact. 0.9. What is the ratio of the Bank branche(per 100,000 adults) in Samoa in 2007 to that in 2009?
Ensure brevity in your answer.  0.89. What is the ratio of the Bank branche(per 100,000 adults) of Cabo Verde in 2008 to that in 2009?
Offer a terse response. 0.91. What is the ratio of the Bank branche(per 100,000 adults) in Latvia in 2008 to that in 2009?
Offer a terse response. 1.04. What is the ratio of the Bank branche(per 100,000 adults) in Poland in 2008 to that in 2009?
Offer a terse response. 0.99. What is the ratio of the Bank branche(per 100,000 adults) of Samoa in 2008 to that in 2009?
Your answer should be compact. 0.88. What is the difference between the highest and the second highest Bank branche(per 100,000 adults) of Cabo Verde?
Your answer should be compact. 2.62. What is the difference between the highest and the second highest Bank branche(per 100,000 adults) in Latvia?
Make the answer very short. 0.72. What is the difference between the highest and the second highest Bank branche(per 100,000 adults) in Poland?
Keep it short and to the point. 0.19. What is the difference between the highest and the second highest Bank branche(per 100,000 adults) of Samoa?
Keep it short and to the point. 3.02. What is the difference between the highest and the lowest Bank branche(per 100,000 adults) of Cabo Verde?
Your answer should be very brief. 12.53. What is the difference between the highest and the lowest Bank branche(per 100,000 adults) of Latvia?
Provide a succinct answer. 5.74. What is the difference between the highest and the lowest Bank branche(per 100,000 adults) in Poland?
Your answer should be compact. 6.31. What is the difference between the highest and the lowest Bank branche(per 100,000 adults) in Samoa?
Offer a terse response. 8.75. 